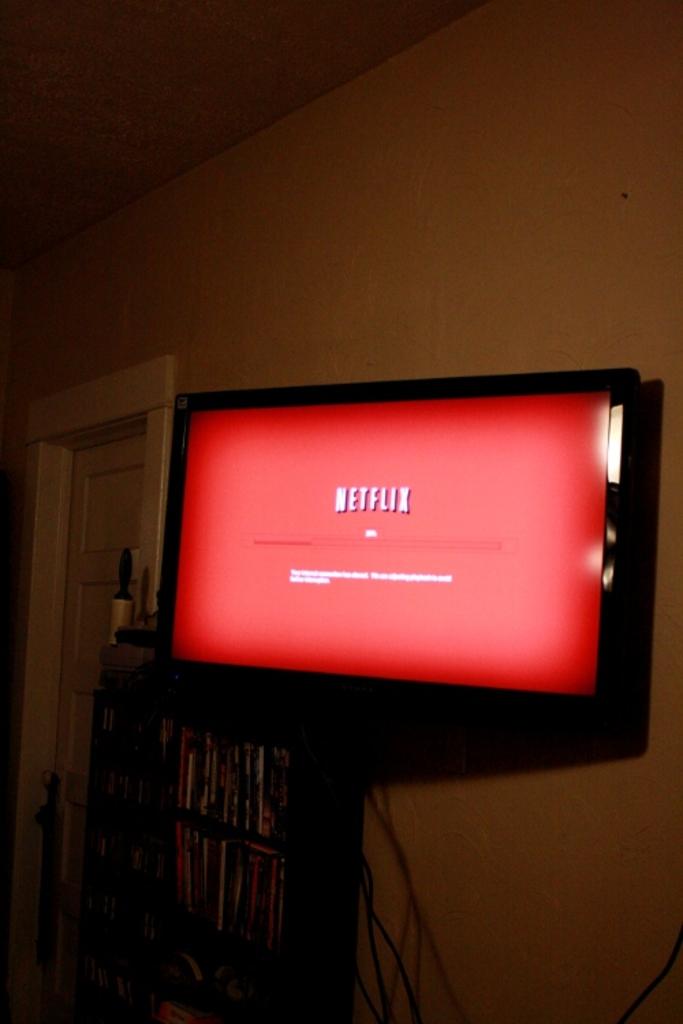What streaming service are they using?
Give a very brief answer. Netflix. 